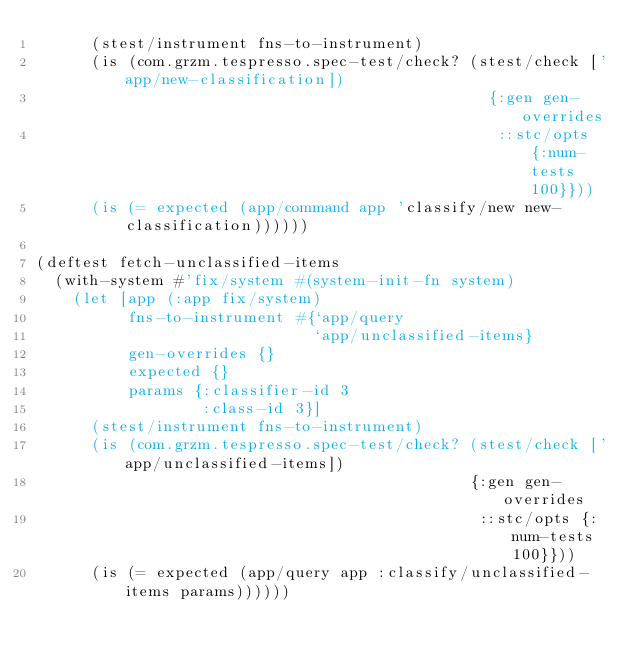<code> <loc_0><loc_0><loc_500><loc_500><_Clojure_>      (stest/instrument fns-to-instrument)
      (is (com.grzm.tespresso.spec-test/check? (stest/check ['app/new-classification])
                                                 {:gen gen-overrides
                                                  ::stc/opts {:num-tests 100}}))
      (is (= expected (app/command app 'classify/new new-classification))))))

(deftest fetch-unclassified-items
  (with-system #'fix/system #(system-init-fn system)
    (let [app (:app fix/system)
          fns-to-instrument #{`app/query
                              `app/unclassified-items}
          gen-overrides {}
          expected {}
          params {:classifier-id 3
                  :class-id 3}]
      (stest/instrument fns-to-instrument)
      (is (com.grzm.tespresso.spec-test/check? (stest/check ['app/unclassified-items])
                                               {:gen gen-overrides
                                                ::stc/opts {:num-tests 100}}))
      (is (= expected (app/query app :classify/unclassified-items params))))))</code> 